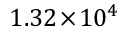<formula> <loc_0><loc_0><loc_500><loc_500>1 . 3 2 \, \times \, 1 0 ^ { 4 }</formula> 